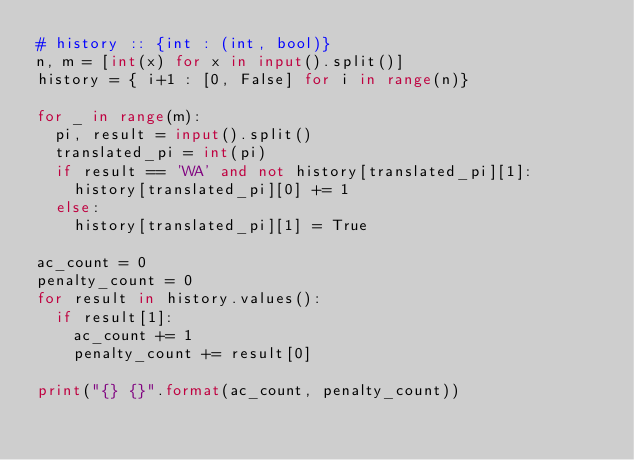Convert code to text. <code><loc_0><loc_0><loc_500><loc_500><_Python_># history :: {int : (int, bool)}
n, m = [int(x) for x in input().split()]
history = { i+1 : [0, False] for i in range(n)}

for _ in range(m):
  pi, result = input().split()
  translated_pi = int(pi)
  if result == 'WA' and not history[translated_pi][1]:
    history[translated_pi][0] += 1
  else:
    history[translated_pi][1] = True

ac_count = 0
penalty_count = 0
for result in history.values():
  if result[1]:
    ac_count += 1
    penalty_count += result[0]

print("{} {}".format(ac_count, penalty_count))</code> 